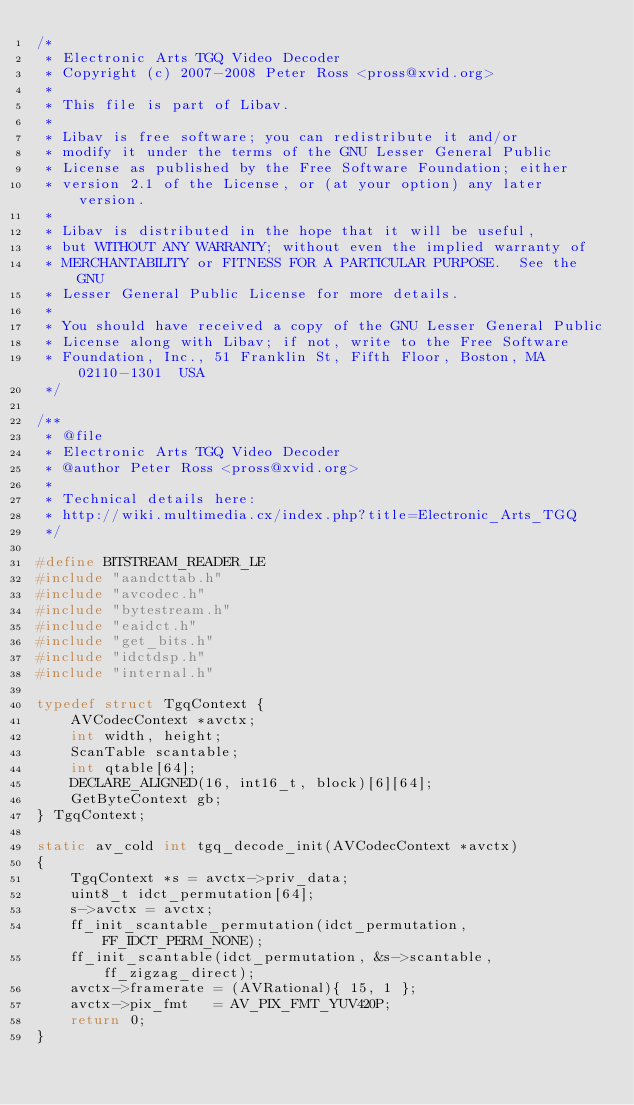<code> <loc_0><loc_0><loc_500><loc_500><_C_>/*
 * Electronic Arts TGQ Video Decoder
 * Copyright (c) 2007-2008 Peter Ross <pross@xvid.org>
 *
 * This file is part of Libav.
 *
 * Libav is free software; you can redistribute it and/or
 * modify it under the terms of the GNU Lesser General Public
 * License as published by the Free Software Foundation; either
 * version 2.1 of the License, or (at your option) any later version.
 *
 * Libav is distributed in the hope that it will be useful,
 * but WITHOUT ANY WARRANTY; without even the implied warranty of
 * MERCHANTABILITY or FITNESS FOR A PARTICULAR PURPOSE.  See the GNU
 * Lesser General Public License for more details.
 *
 * You should have received a copy of the GNU Lesser General Public
 * License along with Libav; if not, write to the Free Software
 * Foundation, Inc., 51 Franklin St, Fifth Floor, Boston, MA  02110-1301  USA
 */

/**
 * @file
 * Electronic Arts TGQ Video Decoder
 * @author Peter Ross <pross@xvid.org>
 *
 * Technical details here:
 * http://wiki.multimedia.cx/index.php?title=Electronic_Arts_TGQ
 */

#define BITSTREAM_READER_LE
#include "aandcttab.h"
#include "avcodec.h"
#include "bytestream.h"
#include "eaidct.h"
#include "get_bits.h"
#include "idctdsp.h"
#include "internal.h"

typedef struct TgqContext {
    AVCodecContext *avctx;
    int width, height;
    ScanTable scantable;
    int qtable[64];
    DECLARE_ALIGNED(16, int16_t, block)[6][64];
    GetByteContext gb;
} TgqContext;

static av_cold int tgq_decode_init(AVCodecContext *avctx)
{
    TgqContext *s = avctx->priv_data;
    uint8_t idct_permutation[64];
    s->avctx = avctx;
    ff_init_scantable_permutation(idct_permutation, FF_IDCT_PERM_NONE);
    ff_init_scantable(idct_permutation, &s->scantable, ff_zigzag_direct);
    avctx->framerate = (AVRational){ 15, 1 };
    avctx->pix_fmt   = AV_PIX_FMT_YUV420P;
    return 0;
}
</code> 